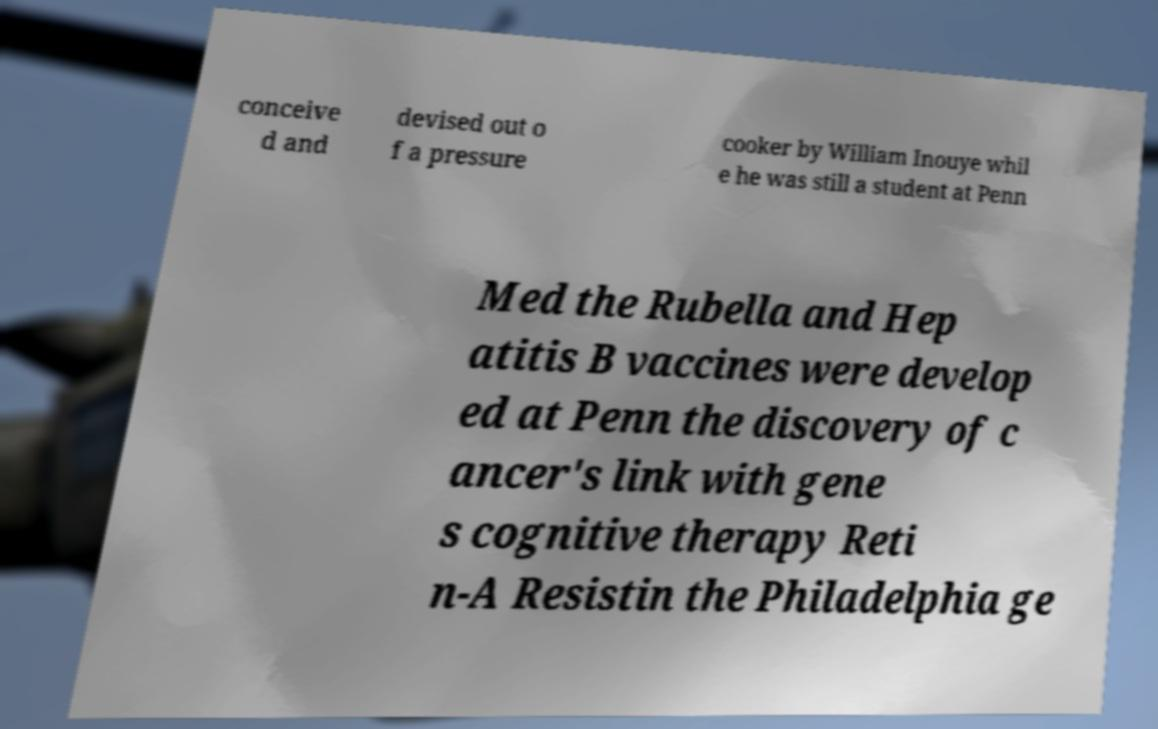Could you assist in decoding the text presented in this image and type it out clearly? conceive d and devised out o f a pressure cooker by William Inouye whil e he was still a student at Penn Med the Rubella and Hep atitis B vaccines were develop ed at Penn the discovery of c ancer's link with gene s cognitive therapy Reti n-A Resistin the Philadelphia ge 